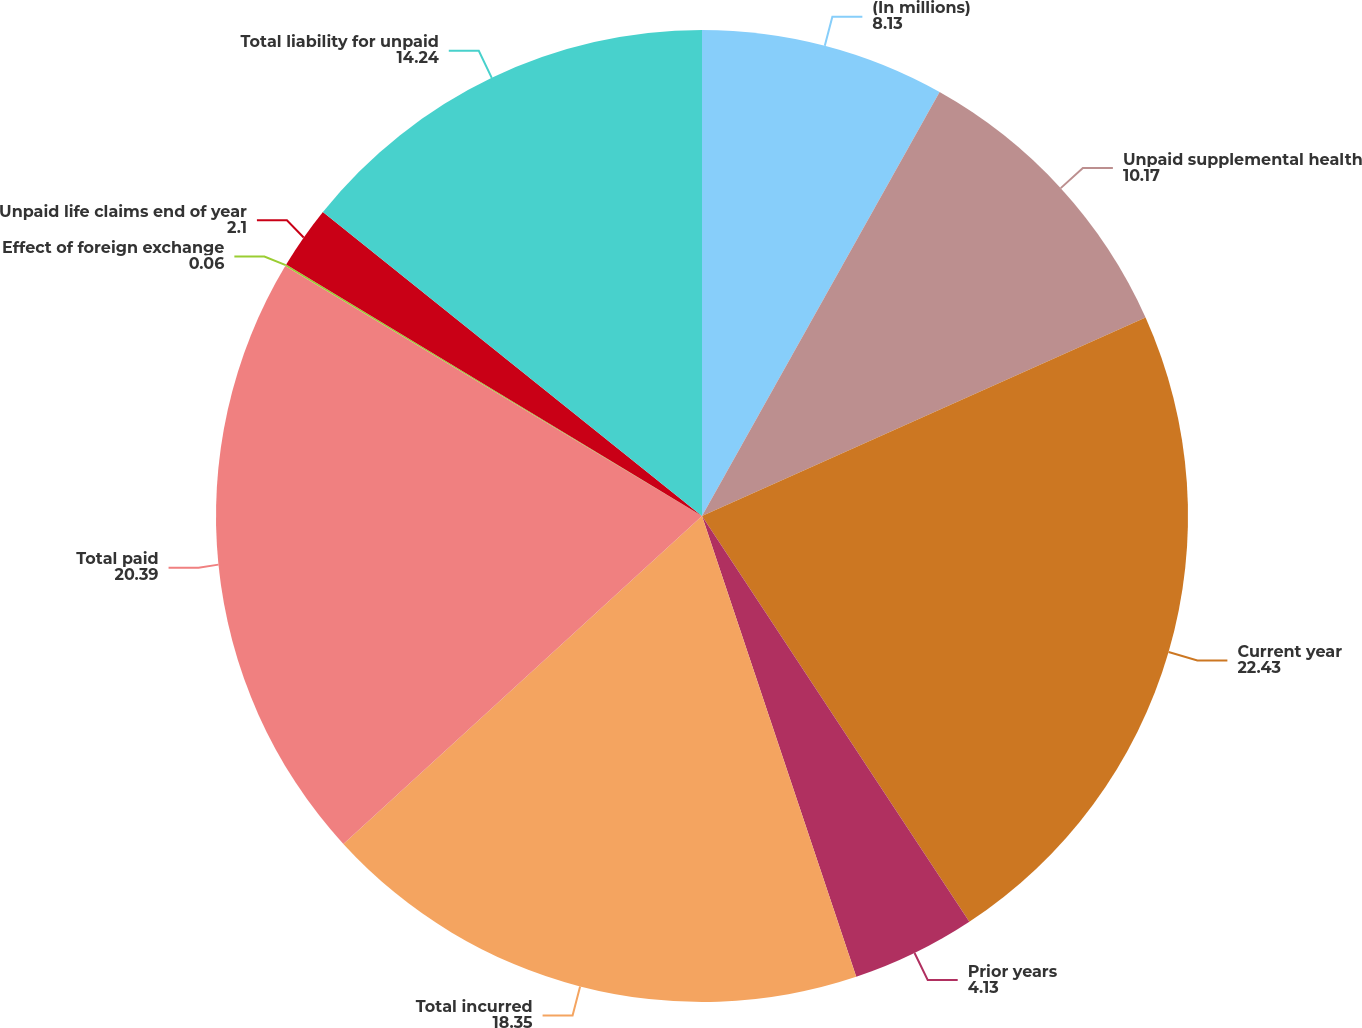Convert chart. <chart><loc_0><loc_0><loc_500><loc_500><pie_chart><fcel>(In millions)<fcel>Unpaid supplemental health<fcel>Current year<fcel>Prior years<fcel>Total incurred<fcel>Total paid<fcel>Effect of foreign exchange<fcel>Unpaid life claims end of year<fcel>Total liability for unpaid<nl><fcel>8.13%<fcel>10.17%<fcel>22.43%<fcel>4.13%<fcel>18.35%<fcel>20.39%<fcel>0.06%<fcel>2.1%<fcel>14.24%<nl></chart> 